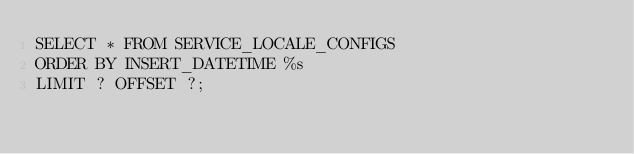<code> <loc_0><loc_0><loc_500><loc_500><_SQL_>SELECT * FROM SERVICE_LOCALE_CONFIGS
ORDER BY INSERT_DATETIME %s
LIMIT ? OFFSET ?;
</code> 